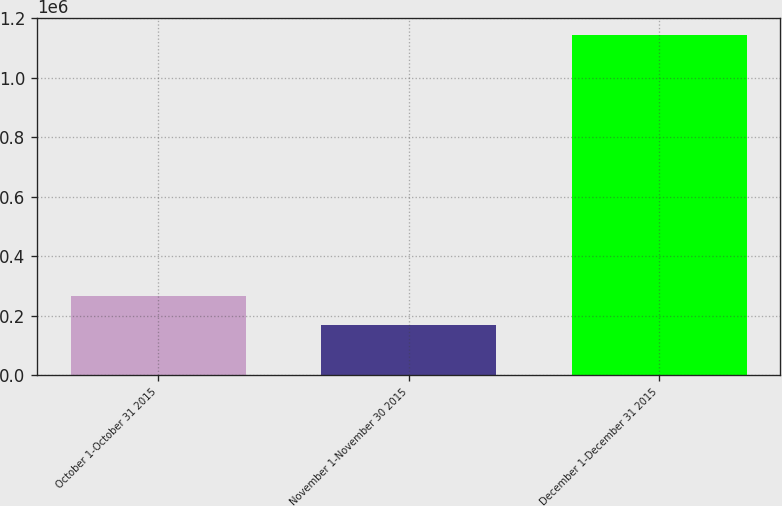Convert chart. <chart><loc_0><loc_0><loc_500><loc_500><bar_chart><fcel>October 1-October 31 2015<fcel>November 1-November 30 2015<fcel>December 1-December 31 2015<nl><fcel>267553<fcel>170254<fcel>1.14325e+06<nl></chart> 